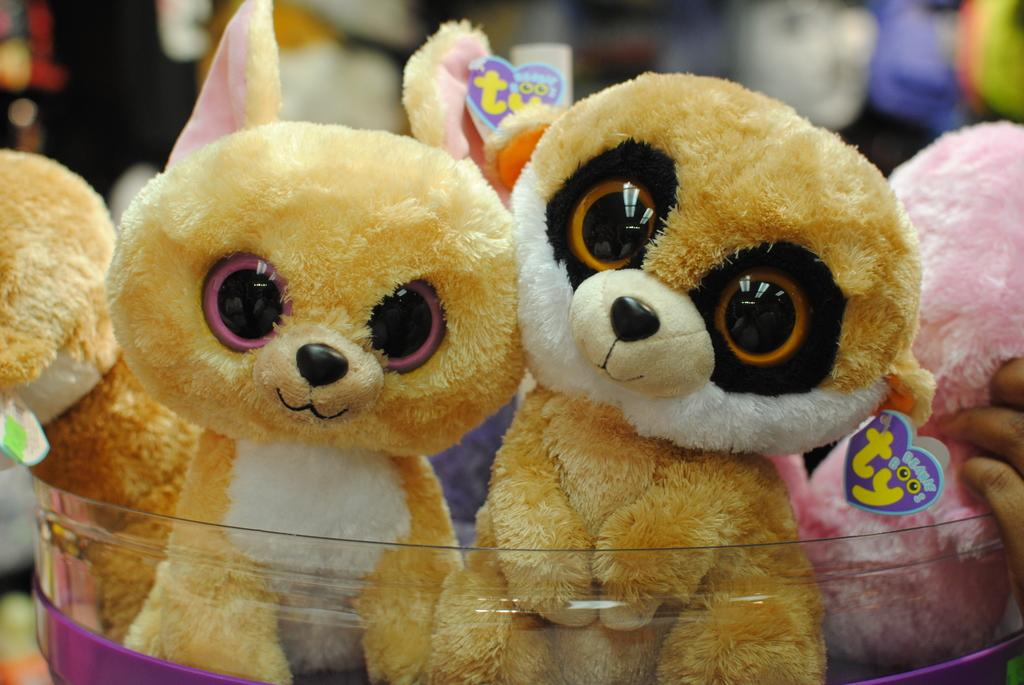Where was the image taken? The image was taken indoors. Can you describe the background of the image? The background of the image is slightly blurred. What objects can be seen in the image? There are toys in the image. What is located at the bottom of the image? There is a tub at the bottom of the image. What is inside the tub? There are toys in the tub. Can you see any worms crawling on the toys in the image? There are no worms visible in the image; it only features toys in a tub. What type of detail can be seen on the rake in the image? There is no rake present in the image. 